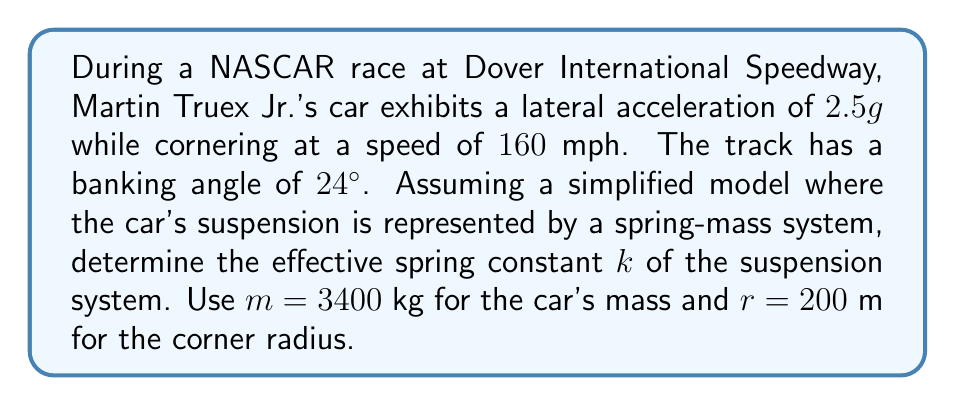Could you help me with this problem? Let's approach this step-by-step:

1) First, we need to calculate the total force acting on the car during cornering. This force is the vector sum of the centripetal force and the component of the car's weight due to the banking.

2) The centripetal force is given by:
   $$F_c = \frac{mv^2}{r}$$
   where $v$ is the velocity in m/s.

3) Convert 160 mph to m/s:
   $$v = 160 \cdot \frac{1609}{3600} \approx 71.5 \text{ m/s}$$

4) Calculate the centripetal force:
   $$F_c = \frac{3400 \cdot 71.5^2}{200} \approx 867,756 \text{ N}$$

5) The component of the car's weight due to banking is:
   $$F_w = mg \sin(24°) = 3400 \cdot 9.8 \cdot \sin(24°) \approx 13,425 \text{ N}$$

6) The total force is:
   $$F_{\text{total}} = \sqrt{F_c^2 + F_w^2} \approx 867,867 \text{ N}$$

7) The lateral acceleration of $2.5g$ means the suspension system experiences a force of:
   $$F_s = 2.5 \cdot mg = 2.5 \cdot 3400 \cdot 9.8 = 83,300 \text{ N}$$

8) Assuming the suspension behaves like a spring, we can use Hooke's law:
   $$F = kx$$
   where $x$ is the displacement of the spring.

9) The displacement can be estimated as the difference between the total force and the suspension force, divided by the car's mass:
   $$x = \frac{F_{\text{total}} - F_s}{m} = \frac{867,867 - 83,300}{3400} \approx 0.231 \text{ m}$$

10) Now we can calculate the spring constant:
    $$k = \frac{F_s}{x} = \frac{83,300}{0.231} \approx 360,606 \text{ N/m}$$
Answer: $k \approx 360,606 \text{ N/m}$ 